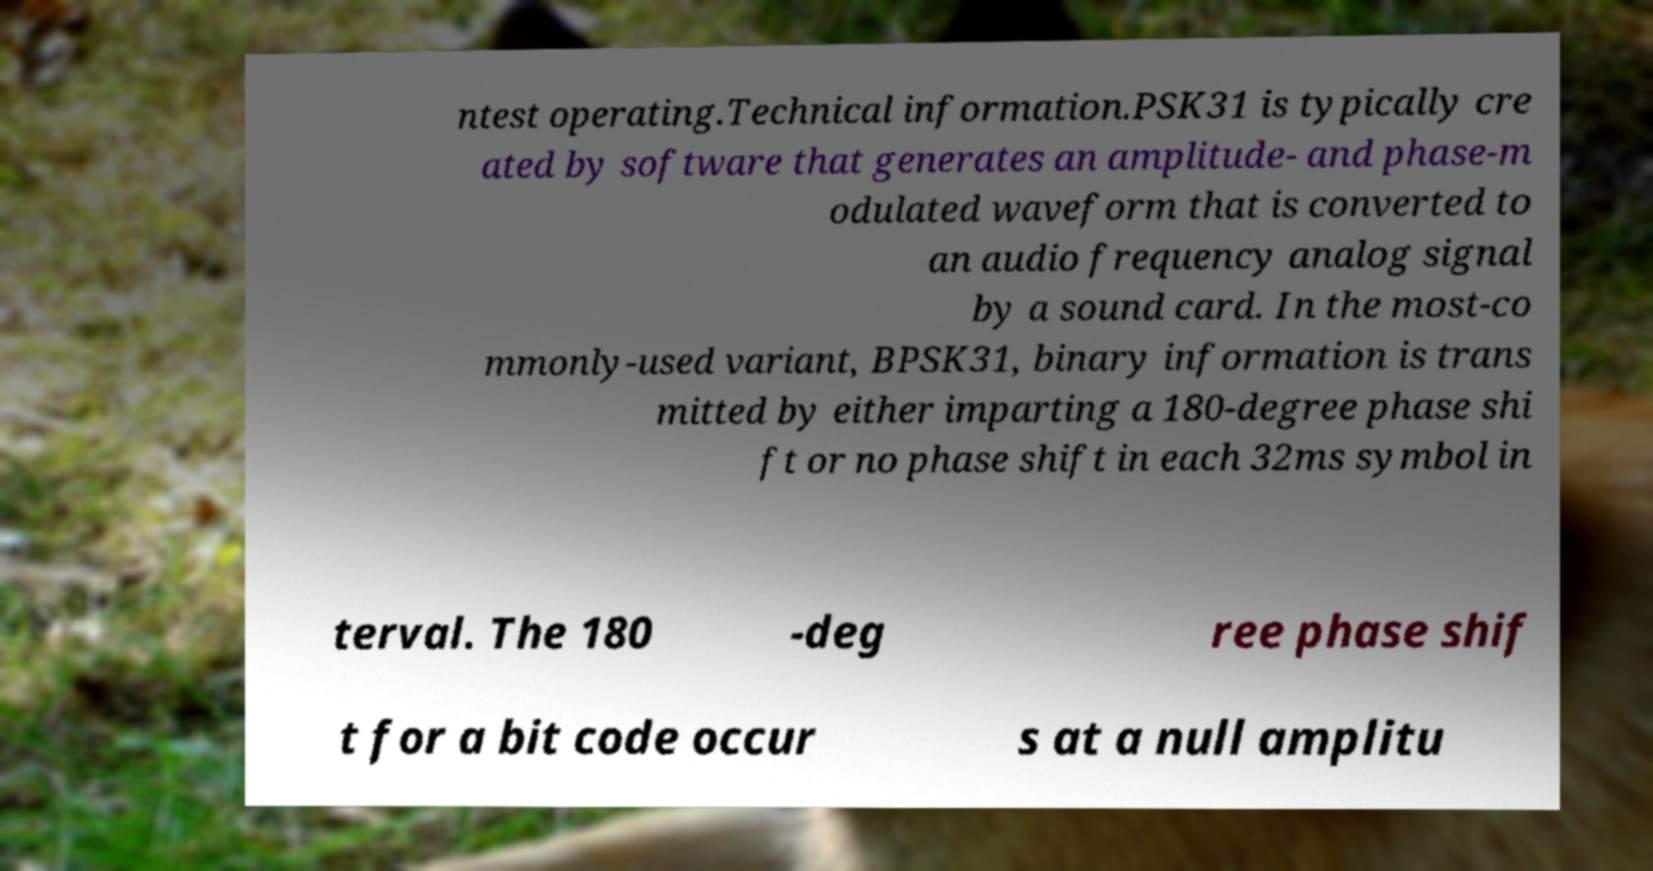Can you read and provide the text displayed in the image?This photo seems to have some interesting text. Can you extract and type it out for me? ntest operating.Technical information.PSK31 is typically cre ated by software that generates an amplitude- and phase-m odulated waveform that is converted to an audio frequency analog signal by a sound card. In the most-co mmonly-used variant, BPSK31, binary information is trans mitted by either imparting a 180-degree phase shi ft or no phase shift in each 32ms symbol in terval. The 180 -deg ree phase shif t for a bit code occur s at a null amplitu 